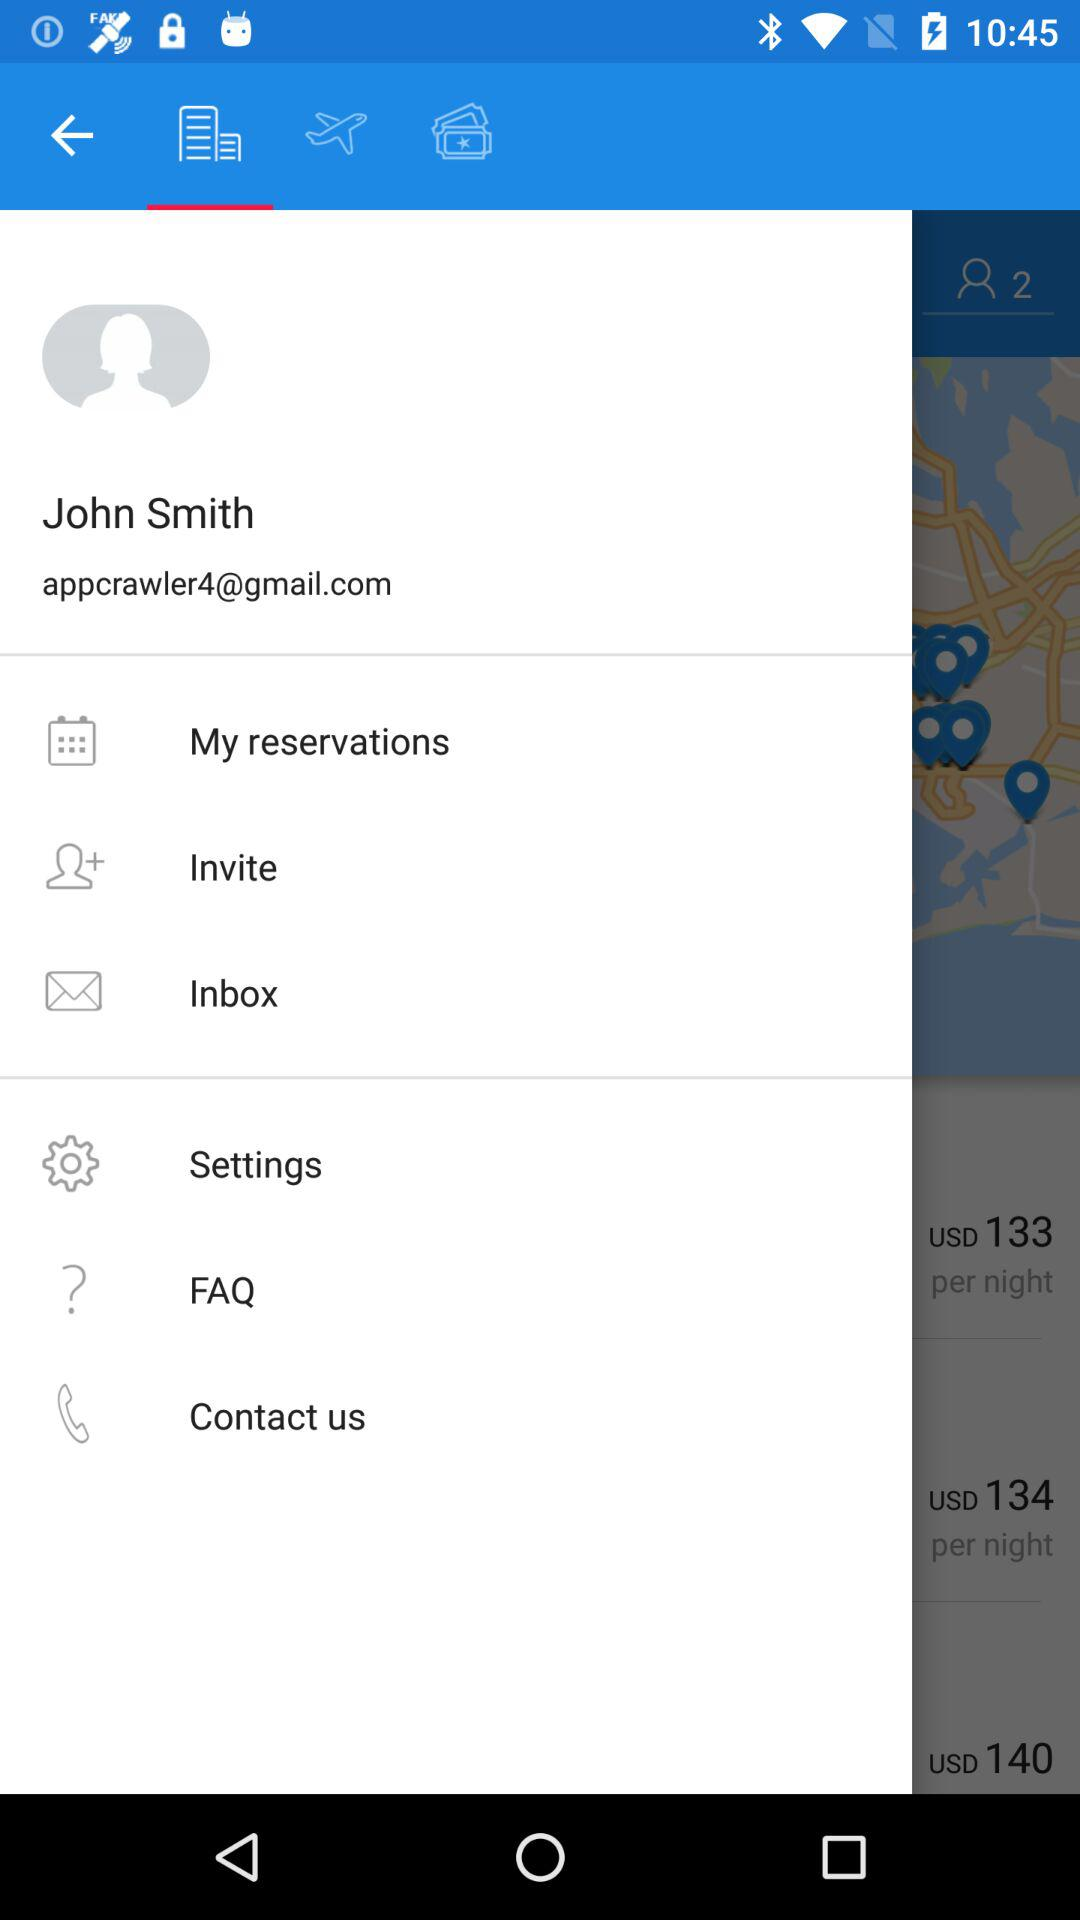What is the username? The username is John Smith. 